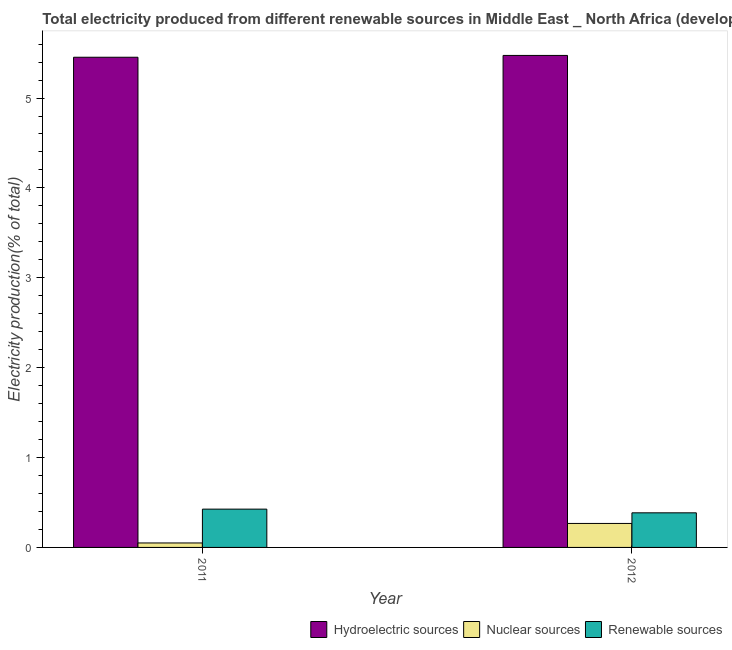How many different coloured bars are there?
Your response must be concise. 3. How many groups of bars are there?
Your answer should be compact. 2. Are the number of bars per tick equal to the number of legend labels?
Ensure brevity in your answer.  Yes. How many bars are there on the 1st tick from the left?
Provide a succinct answer. 3. How many bars are there on the 1st tick from the right?
Offer a terse response. 3. In how many cases, is the number of bars for a given year not equal to the number of legend labels?
Your answer should be very brief. 0. What is the percentage of electricity produced by nuclear sources in 2012?
Provide a short and direct response. 0.27. Across all years, what is the maximum percentage of electricity produced by nuclear sources?
Provide a short and direct response. 0.27. Across all years, what is the minimum percentage of electricity produced by nuclear sources?
Give a very brief answer. 0.05. In which year was the percentage of electricity produced by renewable sources minimum?
Your response must be concise. 2012. What is the total percentage of electricity produced by hydroelectric sources in the graph?
Your answer should be compact. 10.93. What is the difference between the percentage of electricity produced by hydroelectric sources in 2011 and that in 2012?
Offer a terse response. -0.02. What is the difference between the percentage of electricity produced by nuclear sources in 2011 and the percentage of electricity produced by hydroelectric sources in 2012?
Keep it short and to the point. -0.22. What is the average percentage of electricity produced by hydroelectric sources per year?
Offer a very short reply. 5.46. What is the ratio of the percentage of electricity produced by renewable sources in 2011 to that in 2012?
Give a very brief answer. 1.11. Is the percentage of electricity produced by renewable sources in 2011 less than that in 2012?
Keep it short and to the point. No. In how many years, is the percentage of electricity produced by nuclear sources greater than the average percentage of electricity produced by nuclear sources taken over all years?
Offer a terse response. 1. What does the 3rd bar from the left in 2011 represents?
Your answer should be compact. Renewable sources. What does the 2nd bar from the right in 2012 represents?
Ensure brevity in your answer.  Nuclear sources. Is it the case that in every year, the sum of the percentage of electricity produced by hydroelectric sources and percentage of electricity produced by nuclear sources is greater than the percentage of electricity produced by renewable sources?
Your answer should be compact. Yes. Are all the bars in the graph horizontal?
Give a very brief answer. No. Where does the legend appear in the graph?
Your response must be concise. Bottom right. How are the legend labels stacked?
Your answer should be compact. Horizontal. What is the title of the graph?
Offer a terse response. Total electricity produced from different renewable sources in Middle East _ North Africa (developing only). Does "Liquid fuel" appear as one of the legend labels in the graph?
Your answer should be compact. No. What is the label or title of the Y-axis?
Keep it short and to the point. Electricity production(% of total). What is the Electricity production(% of total) of Hydroelectric sources in 2011?
Your answer should be very brief. 5.45. What is the Electricity production(% of total) of Nuclear sources in 2011?
Keep it short and to the point. 0.05. What is the Electricity production(% of total) in Renewable sources in 2011?
Your answer should be very brief. 0.43. What is the Electricity production(% of total) in Hydroelectric sources in 2012?
Give a very brief answer. 5.47. What is the Electricity production(% of total) in Nuclear sources in 2012?
Offer a very short reply. 0.27. What is the Electricity production(% of total) of Renewable sources in 2012?
Provide a short and direct response. 0.38. Across all years, what is the maximum Electricity production(% of total) in Hydroelectric sources?
Offer a very short reply. 5.47. Across all years, what is the maximum Electricity production(% of total) in Nuclear sources?
Ensure brevity in your answer.  0.27. Across all years, what is the maximum Electricity production(% of total) in Renewable sources?
Provide a short and direct response. 0.43. Across all years, what is the minimum Electricity production(% of total) of Hydroelectric sources?
Offer a very short reply. 5.45. Across all years, what is the minimum Electricity production(% of total) in Nuclear sources?
Ensure brevity in your answer.  0.05. Across all years, what is the minimum Electricity production(% of total) in Renewable sources?
Ensure brevity in your answer.  0.38. What is the total Electricity production(% of total) in Hydroelectric sources in the graph?
Your answer should be very brief. 10.93. What is the total Electricity production(% of total) of Nuclear sources in the graph?
Give a very brief answer. 0.32. What is the total Electricity production(% of total) in Renewable sources in the graph?
Your answer should be compact. 0.81. What is the difference between the Electricity production(% of total) in Hydroelectric sources in 2011 and that in 2012?
Give a very brief answer. -0.02. What is the difference between the Electricity production(% of total) of Nuclear sources in 2011 and that in 2012?
Keep it short and to the point. -0.22. What is the difference between the Electricity production(% of total) of Renewable sources in 2011 and that in 2012?
Your response must be concise. 0.04. What is the difference between the Electricity production(% of total) of Hydroelectric sources in 2011 and the Electricity production(% of total) of Nuclear sources in 2012?
Give a very brief answer. 5.19. What is the difference between the Electricity production(% of total) in Hydroelectric sources in 2011 and the Electricity production(% of total) in Renewable sources in 2012?
Provide a succinct answer. 5.07. What is the difference between the Electricity production(% of total) in Nuclear sources in 2011 and the Electricity production(% of total) in Renewable sources in 2012?
Your answer should be very brief. -0.34. What is the average Electricity production(% of total) of Hydroelectric sources per year?
Your answer should be compact. 5.46. What is the average Electricity production(% of total) in Nuclear sources per year?
Your answer should be compact. 0.16. What is the average Electricity production(% of total) in Renewable sources per year?
Provide a short and direct response. 0.41. In the year 2011, what is the difference between the Electricity production(% of total) in Hydroelectric sources and Electricity production(% of total) in Nuclear sources?
Your answer should be very brief. 5.4. In the year 2011, what is the difference between the Electricity production(% of total) of Hydroelectric sources and Electricity production(% of total) of Renewable sources?
Make the answer very short. 5.03. In the year 2011, what is the difference between the Electricity production(% of total) of Nuclear sources and Electricity production(% of total) of Renewable sources?
Offer a very short reply. -0.38. In the year 2012, what is the difference between the Electricity production(% of total) of Hydroelectric sources and Electricity production(% of total) of Nuclear sources?
Provide a short and direct response. 5.21. In the year 2012, what is the difference between the Electricity production(% of total) of Hydroelectric sources and Electricity production(% of total) of Renewable sources?
Make the answer very short. 5.09. In the year 2012, what is the difference between the Electricity production(% of total) in Nuclear sources and Electricity production(% of total) in Renewable sources?
Keep it short and to the point. -0.12. What is the ratio of the Electricity production(% of total) of Hydroelectric sources in 2011 to that in 2012?
Keep it short and to the point. 1. What is the ratio of the Electricity production(% of total) of Nuclear sources in 2011 to that in 2012?
Provide a short and direct response. 0.19. What is the ratio of the Electricity production(% of total) of Renewable sources in 2011 to that in 2012?
Keep it short and to the point. 1.11. What is the difference between the highest and the second highest Electricity production(% of total) in Hydroelectric sources?
Your answer should be very brief. 0.02. What is the difference between the highest and the second highest Electricity production(% of total) in Nuclear sources?
Offer a terse response. 0.22. What is the difference between the highest and the second highest Electricity production(% of total) of Renewable sources?
Your answer should be compact. 0.04. What is the difference between the highest and the lowest Electricity production(% of total) in Hydroelectric sources?
Your answer should be compact. 0.02. What is the difference between the highest and the lowest Electricity production(% of total) in Nuclear sources?
Make the answer very short. 0.22. What is the difference between the highest and the lowest Electricity production(% of total) in Renewable sources?
Make the answer very short. 0.04. 